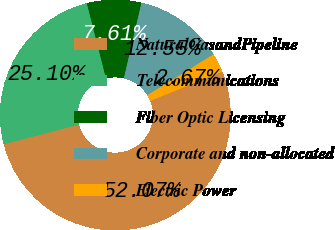<chart> <loc_0><loc_0><loc_500><loc_500><pie_chart><fcel>NaturalGasandPipeline<fcel>Telecommunications<fcel>Fiber Optic Licensing<fcel>Corporate and non-allocated<fcel>Electric Power<nl><fcel>52.06%<fcel>25.1%<fcel>7.61%<fcel>12.55%<fcel>2.67%<nl></chart> 